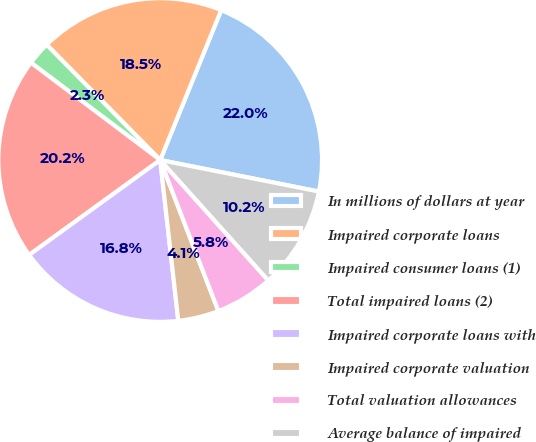Convert chart. <chart><loc_0><loc_0><loc_500><loc_500><pie_chart><fcel>In millions of dollars at year<fcel>Impaired corporate loans<fcel>Impaired consumer loans (1)<fcel>Total impaired loans (2)<fcel>Impaired corporate loans with<fcel>Impaired corporate valuation<fcel>Total valuation allowances<fcel>Average balance of impaired<nl><fcel>21.97%<fcel>18.53%<fcel>2.35%<fcel>20.25%<fcel>16.81%<fcel>4.07%<fcel>5.79%<fcel>10.24%<nl></chart> 